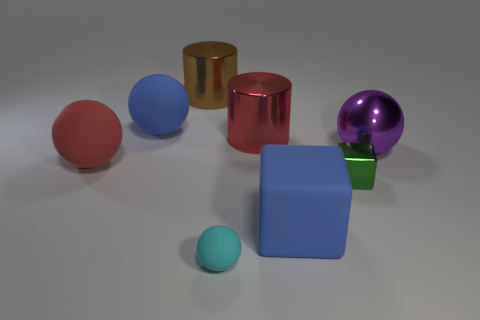Subtract 3 spheres. How many spheres are left? 1 Subtract all brown cylinders. How many cylinders are left? 1 Subtract all blue spheres. How many spheres are left? 3 Subtract all red cylinders. How many purple spheres are left? 1 Subtract 0 cyan cubes. How many objects are left? 8 Subtract all cylinders. How many objects are left? 6 Subtract all blue blocks. Subtract all green cylinders. How many blocks are left? 1 Subtract all small yellow metal balls. Subtract all red shiny cylinders. How many objects are left? 7 Add 3 big spheres. How many big spheres are left? 6 Add 8 large brown metal objects. How many large brown metal objects exist? 9 